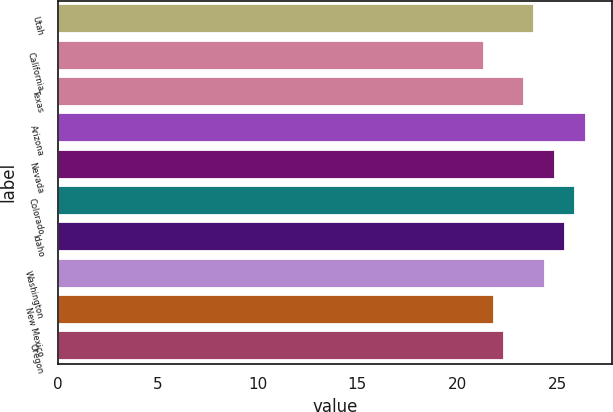<chart> <loc_0><loc_0><loc_500><loc_500><bar_chart><fcel>Utah<fcel>California<fcel>Texas<fcel>Arizona<fcel>Nevada<fcel>Colorado<fcel>Idaho<fcel>Washington<fcel>New Mexico<fcel>Oregon<nl><fcel>23.86<fcel>21.32<fcel>23.35<fcel>26.44<fcel>24.88<fcel>25.9<fcel>25.39<fcel>24.37<fcel>21.83<fcel>22.34<nl></chart> 